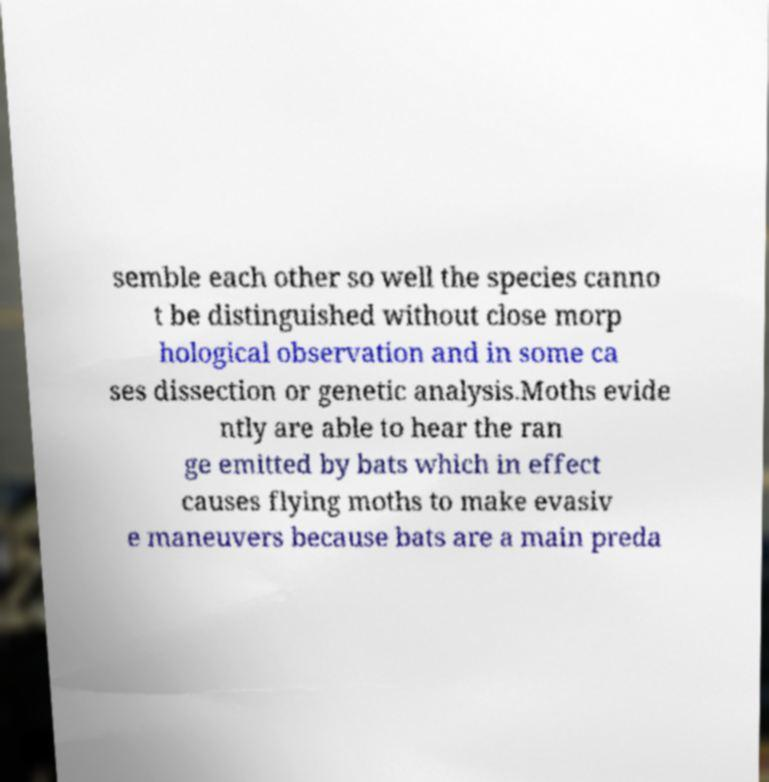I need the written content from this picture converted into text. Can you do that? semble each other so well the species canno t be distinguished without close morp hological observation and in some ca ses dissection or genetic analysis.Moths evide ntly are able to hear the ran ge emitted by bats which in effect causes flying moths to make evasiv e maneuvers because bats are a main preda 